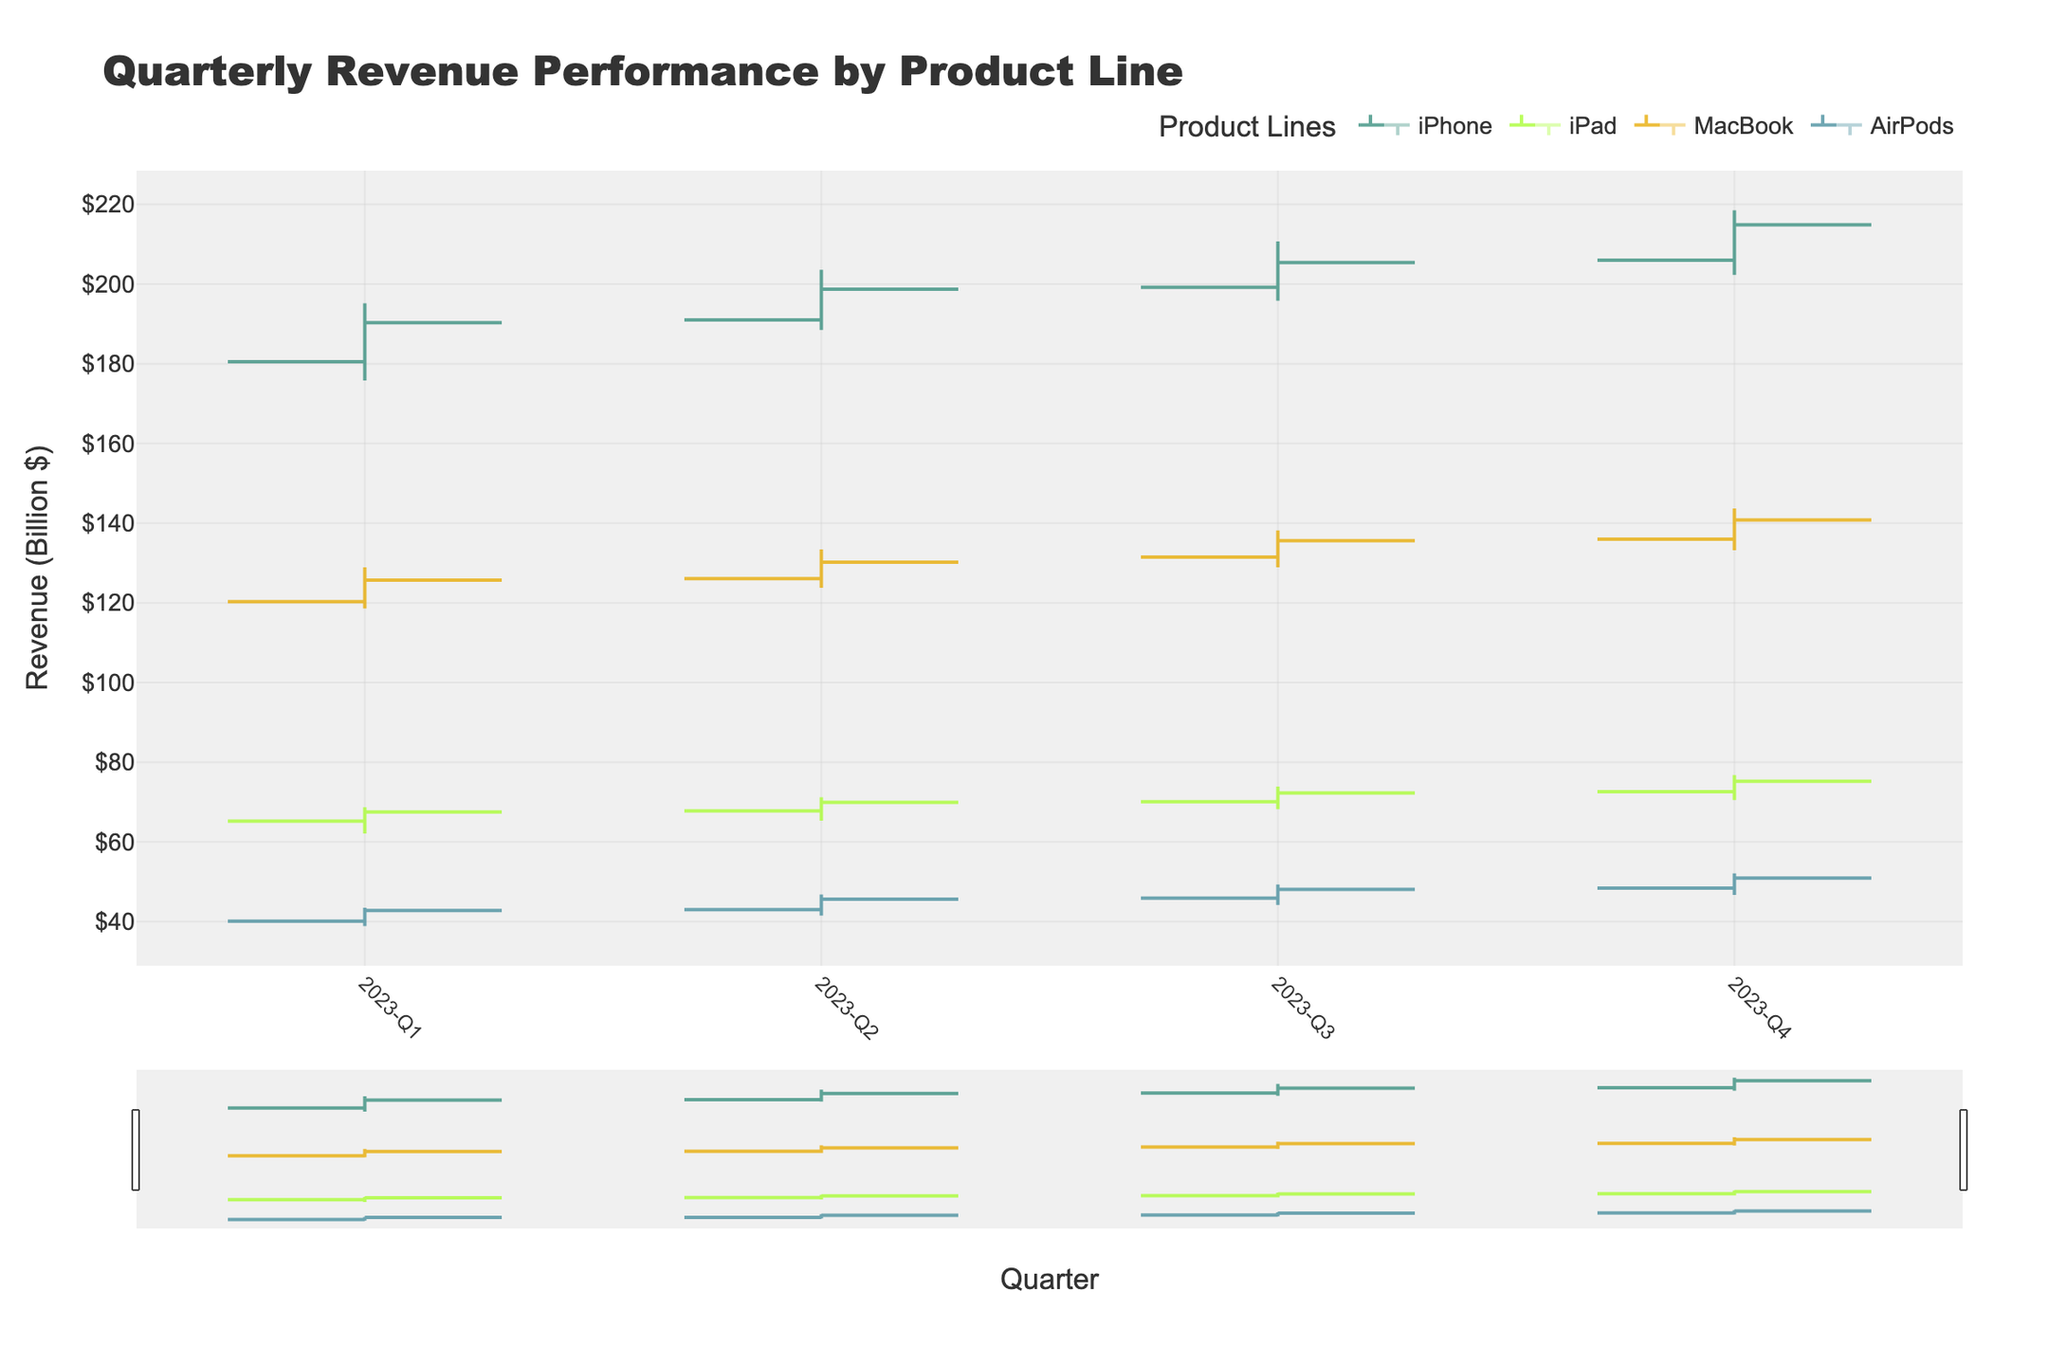What is the title of the chart? The title of the chart is located at the top of the figure and typically provides a concise description of what the chart represents.
Answer: Quarterly Revenue Performance by Product Line How many different products are shown in the chart? By examining the legend or the different colored lines within the chart, the number of unique product lines can be determined.
Answer: 4 Which quarter has the highest closing value for the iPhone? Look for the iPhone's closing prices across all quarters in the chart, then identify the quarter with the highest value. In Q4, the iPhone closes at 214.9, which is the highest among all quarters.
Answer: 2023-Q4 What is the average closing revenue for the MacBook across all quarters? Identify the MacBook's closing values for all four quarters (125.7, 130.2, 135.6, 140.8) and calculate their average. The steps are as follows: Sum the values: 125.7 + 130.2 + 135.6 + 140.8 = 532.3. Divide by the number of quarters: 532.3 / 4 = 133.1.
Answer: 133.1 Compare the opening revenue of the AirPods in Q1 and Q4. Which quarter has the higher opening revenue? Locate the opening values for AirPods in Q1 (40.1) and Q4 (48.4), then compare these values. Q4's opening value (48.4) is higher than Q1's (40.1).
Answer: Q4 In which quarter did the iPad experience its lowest low point? Examine the low values for the iPad in each quarter and determine which one is the lowest. In Q1, the lowest point for iPad is 62.1, which is the lowest among all quarters.
Answer: 2023-Q1 What is the overall trend in the closing values for the iPhone across the four quarters? Analyze the closing values of the iPhone for all quarters (190.3, 198.7, 205.4, and 214.9). Observing these values, the trend is increasing.
Answer: Increasing How much did the revenue for AirPods increase from its lowest price in Q2 to its highest price in Q4? Identify the lowest value in Q2 (41.5) and the highest value in Q4 (52.1) for AirPods. Calculate their difference: 52.1 - 41.5 = 10.6.
Answer: 10.6 Which product had the most stable closing prices across the four quarters? Assess the closing values for each product across the four quarters and determine which product has the smallest variation. Based on the small differences in values for each quarter, the iPad consistently varies less (67.5, 69.9, 72.3, 75.2).
Answer: iPad 